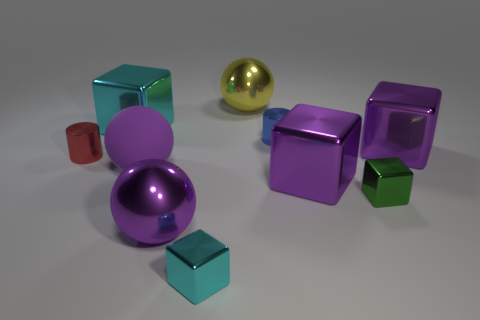There is a cyan block that is the same size as the yellow sphere; what is its material?
Your answer should be compact. Metal. There is a large ball that is behind the small cylinder that is left of the shiny sphere that is in front of the large yellow shiny object; what is its color?
Your answer should be compact. Yellow. How many green shiny things are the same size as the purple rubber thing?
Your answer should be very brief. 0. There is a big thing left of the purple rubber object; what is its color?
Provide a short and direct response. Cyan. What number of other objects are the same size as the purple metallic sphere?
Offer a very short reply. 5. What size is the thing that is to the left of the large matte ball and in front of the tiny blue metallic cylinder?
Your answer should be compact. Small. Is the color of the matte thing the same as the metal ball that is to the left of the big yellow object?
Your answer should be compact. Yes. Are there any big purple metal things that have the same shape as the purple rubber object?
Provide a succinct answer. Yes. How many things are cubes or small metallic cylinders in front of the tiny blue metal cylinder?
Offer a terse response. 6. What number of other objects are there of the same material as the small red object?
Make the answer very short. 8. 